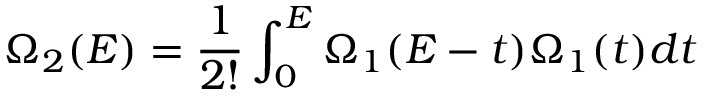<formula> <loc_0><loc_0><loc_500><loc_500>\Omega _ { 2 } ( E ) = \frac { 1 } { 2 ! } \int _ { 0 } ^ { E } \Omega _ { 1 } ( E - t ) \Omega _ { 1 } ( t ) d t</formula> 